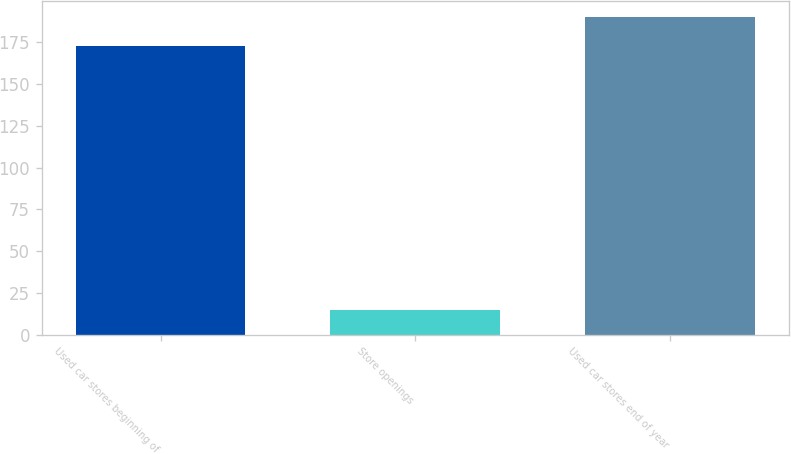Convert chart. <chart><loc_0><loc_0><loc_500><loc_500><bar_chart><fcel>Used car stores beginning of<fcel>Store openings<fcel>Used car stores end of year<nl><fcel>173<fcel>15<fcel>190.3<nl></chart> 